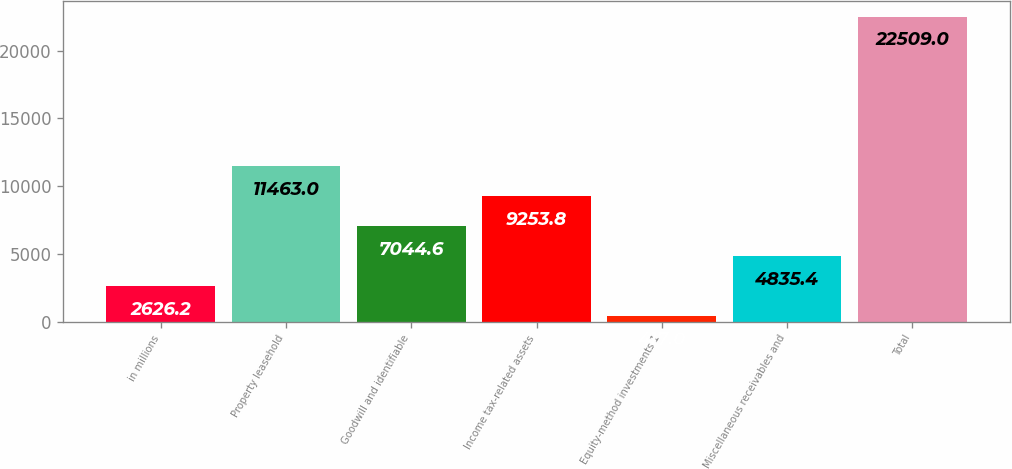<chart> <loc_0><loc_0><loc_500><loc_500><bar_chart><fcel>in millions<fcel>Property leasehold<fcel>Goodwill and identifiable<fcel>Income tax-related assets<fcel>Equity-method investments 1<fcel>Miscellaneous receivables and<fcel>Total<nl><fcel>2626.2<fcel>11463<fcel>7044.6<fcel>9253.8<fcel>417<fcel>4835.4<fcel>22509<nl></chart> 